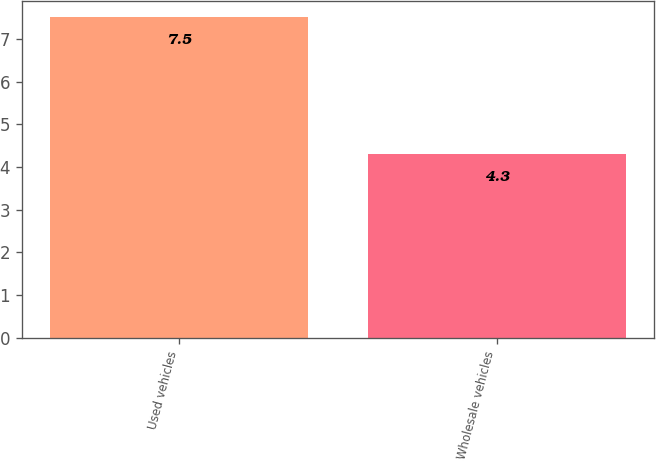Convert chart to OTSL. <chart><loc_0><loc_0><loc_500><loc_500><bar_chart><fcel>Used vehicles<fcel>Wholesale vehicles<nl><fcel>7.5<fcel>4.3<nl></chart> 